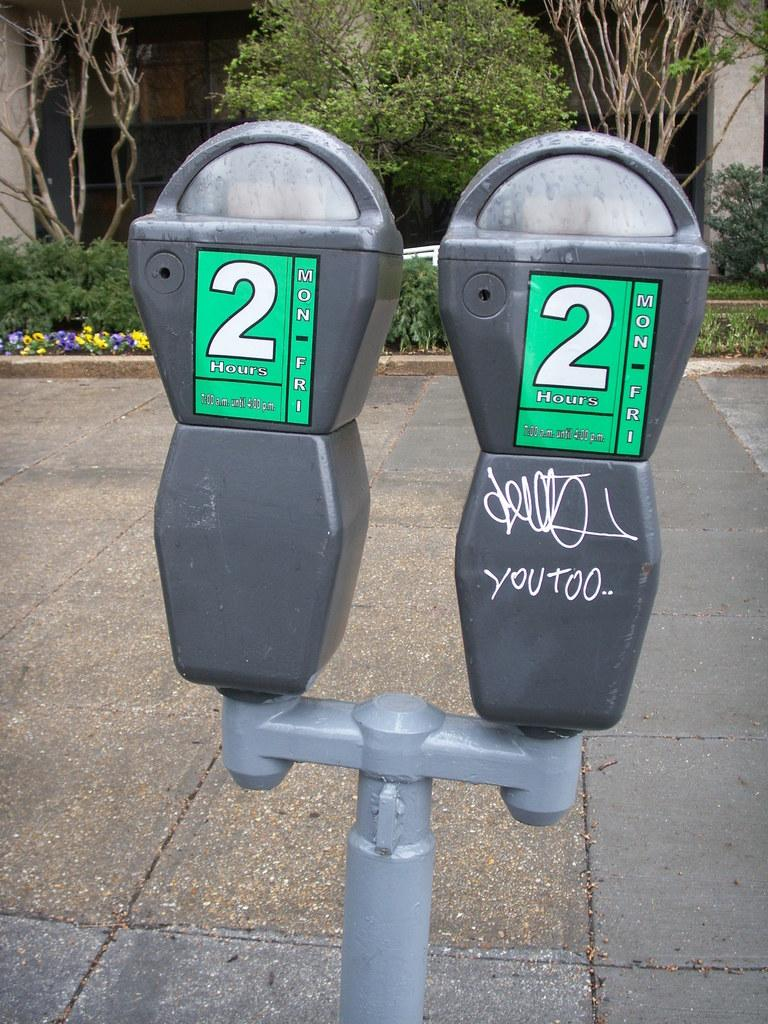Provide a one-sentence caption for the provided image. Two parking meter with the number "2" on them. 